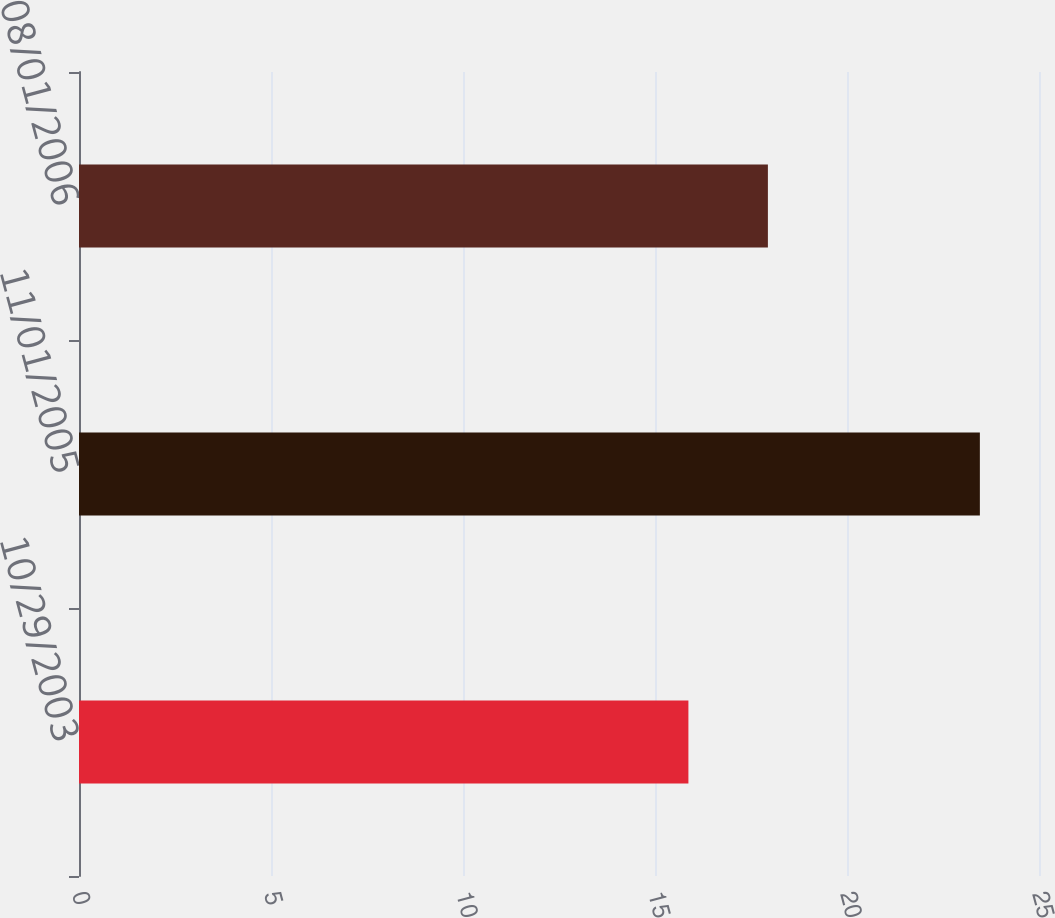<chart> <loc_0><loc_0><loc_500><loc_500><bar_chart><fcel>10/29/2003<fcel>11/01/2005<fcel>08/01/2006<nl><fcel>15.87<fcel>23.46<fcel>17.94<nl></chart> 